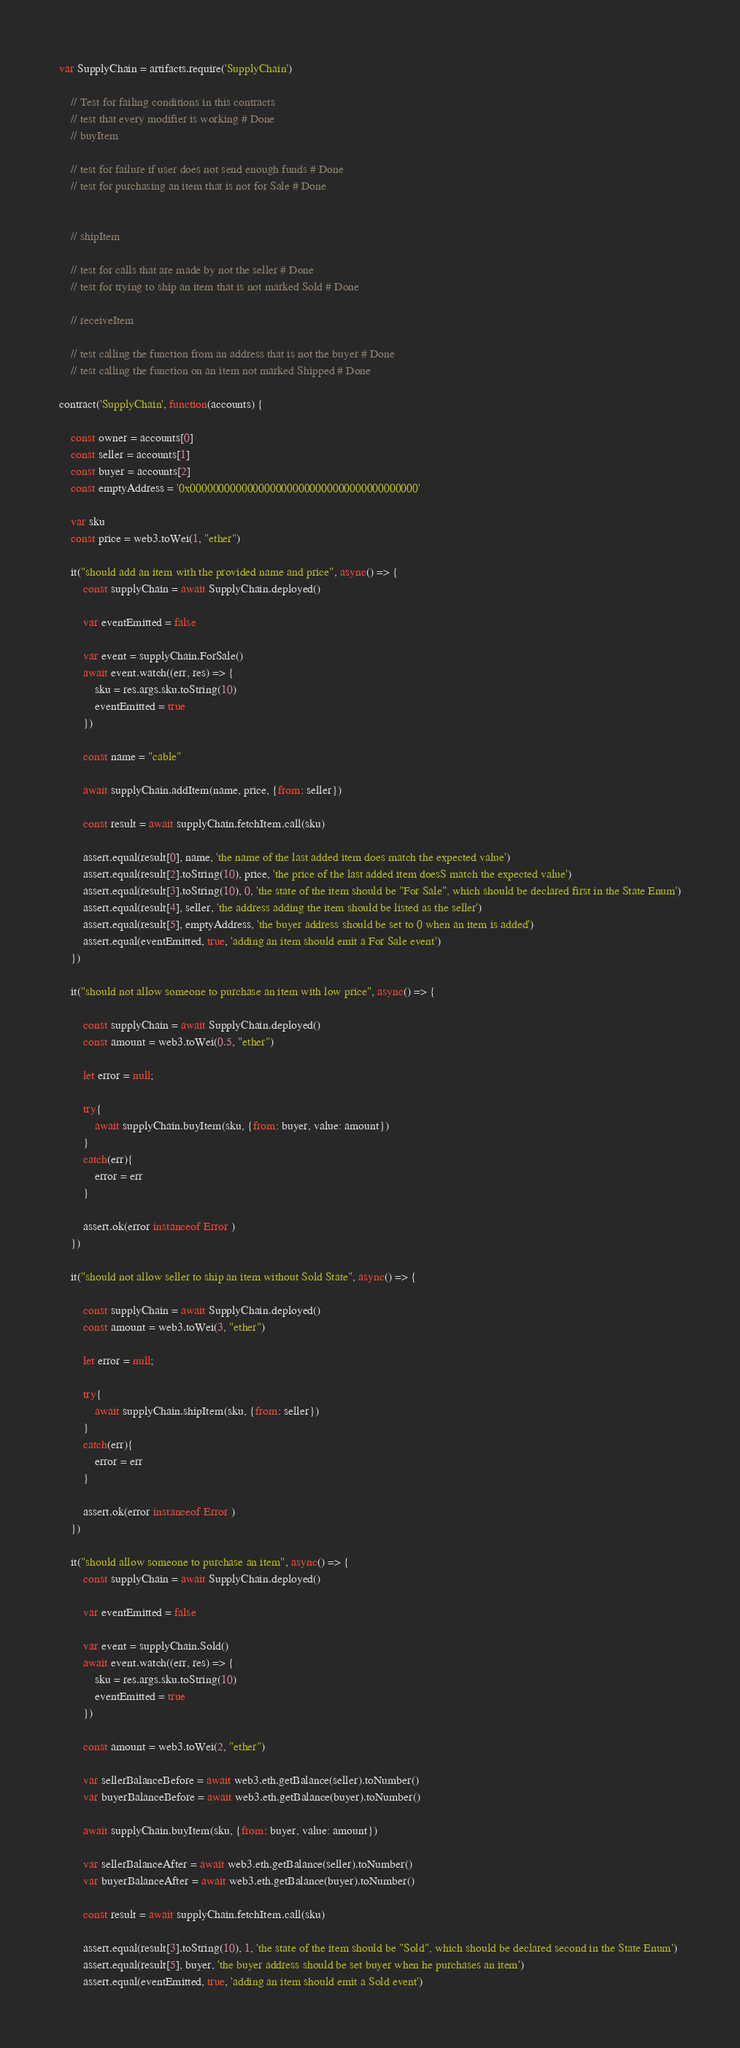<code> <loc_0><loc_0><loc_500><loc_500><_JavaScript_>var SupplyChain = artifacts.require('SupplyChain')

    // Test for failing conditions in this contracts
    // test that every modifier is working # Done
    // buyItem

    // test for failure if user does not send enough funds # Done
    // test for purchasing an item that is not for Sale # Done


    // shipItem

    // test for calls that are made by not the seller # Done
    // test for trying to ship an item that is not marked Sold # Done

    // receiveItem

    // test calling the function from an address that is not the buyer # Done
    // test calling the function on an item not marked Shipped # Done

contract('SupplyChain', function(accounts) {

    const owner = accounts[0]
    const seller = accounts[1]
    const buyer = accounts[2]
    const emptyAddress = '0x0000000000000000000000000000000000000000'

    var sku
    const price = web3.toWei(1, "ether")

    it("should add an item with the provided name and price", async() => {
        const supplyChain = await SupplyChain.deployed()

        var eventEmitted = false

        var event = supplyChain.ForSale()
        await event.watch((err, res) => {
            sku = res.args.sku.toString(10)
            eventEmitted = true
        })

        const name = "cable"

        await supplyChain.addItem(name, price, {from: seller})

        const result = await supplyChain.fetchItem.call(sku)

        assert.equal(result[0], name, 'the name of the last added item does match the expected value')
        assert.equal(result[2].toString(10), price, 'the price of the last added item doesS match the expected value')
        assert.equal(result[3].toString(10), 0, 'the state of the item should be "For Sale", which should be declared first in the State Enum')
        assert.equal(result[4], seller, 'the address adding the item should be listed as the seller')
        assert.equal(result[5], emptyAddress, 'the buyer address should be set to 0 when an item is added')
        assert.equal(eventEmitted, true, 'adding an item should emit a For Sale event')
    })

    it("should not allow someone to purchase an item with low price", async() => {
        
        const supplyChain = await SupplyChain.deployed()
        const amount = web3.toWei(0.5, "ether")

        let error = null;

        try{
            await supplyChain.buyItem(sku, {from: buyer, value: amount})
        }
        catch(err){
            error = err
        }

        assert.ok(error instanceof Error )
    })

    it("should not allow seller to ship an item without Sold State", async() => {

        const supplyChain = await SupplyChain.deployed()
        const amount = web3.toWei(3, "ether")

        let error = null;

        try{
            await supplyChain.shipItem(sku, {from: seller})
        }
        catch(err){
            error = err
        }

        assert.ok(error instanceof Error )
    })

    it("should allow someone to purchase an item", async() => {
        const supplyChain = await SupplyChain.deployed()

        var eventEmitted = false

        var event = supplyChain.Sold()
        await event.watch((err, res) => {
            sku = res.args.sku.toString(10)
            eventEmitted = true
        })

        const amount = web3.toWei(2, "ether")

        var sellerBalanceBefore = await web3.eth.getBalance(seller).toNumber()
        var buyerBalanceBefore = await web3.eth.getBalance(buyer).toNumber()

        await supplyChain.buyItem(sku, {from: buyer, value: amount})

        var sellerBalanceAfter = await web3.eth.getBalance(seller).toNumber()
        var buyerBalanceAfter = await web3.eth.getBalance(buyer).toNumber()

        const result = await supplyChain.fetchItem.call(sku)

        assert.equal(result[3].toString(10), 1, 'the state of the item should be "Sold", which should be declared second in the State Enum')
        assert.equal(result[5], buyer, 'the buyer address should be set buyer when he purchases an item')
        assert.equal(eventEmitted, true, 'adding an item should emit a Sold event')</code> 